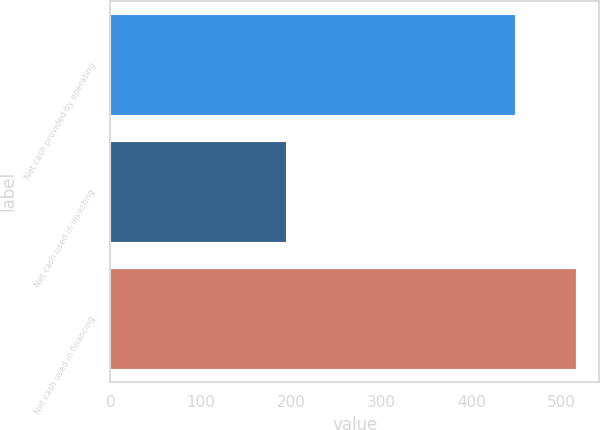<chart> <loc_0><loc_0><loc_500><loc_500><bar_chart><fcel>Net cash provided by operating<fcel>Net cash used in investing<fcel>Net cash used in financing<nl><fcel>448.5<fcel>194.6<fcel>515.9<nl></chart> 